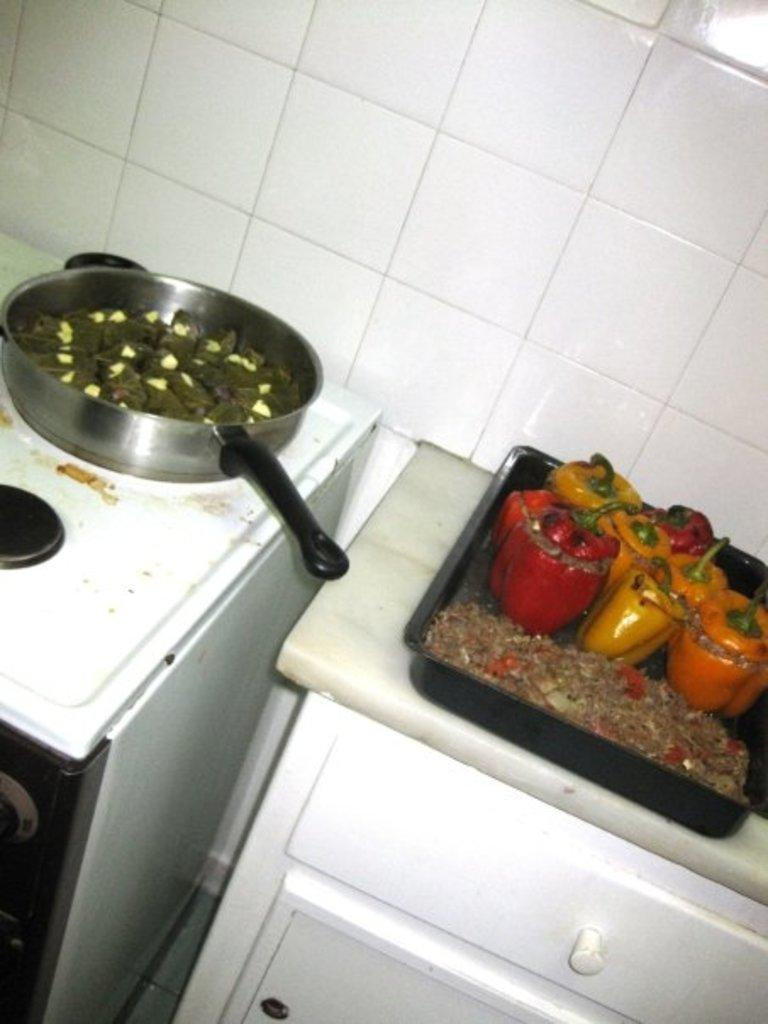What is on the tray that is visible in the image? There is a tray with food in the image. What else can be seen on a surface in the image? There is a container on a surface in the image. What is visible in the background of the image? There is a wall visible in the image. What type of rail can be seen in the image? There is no rail present in the image. What design is featured on the wall in the image? The provided facts do not mention any specific design on the wall. What type of sponge is being used to clean the container in the image? There is no indication of any cleaning activity or sponge present in the image. 